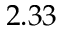Convert formula to latex. <formula><loc_0><loc_0><loc_500><loc_500>2 . 3 3</formula> 